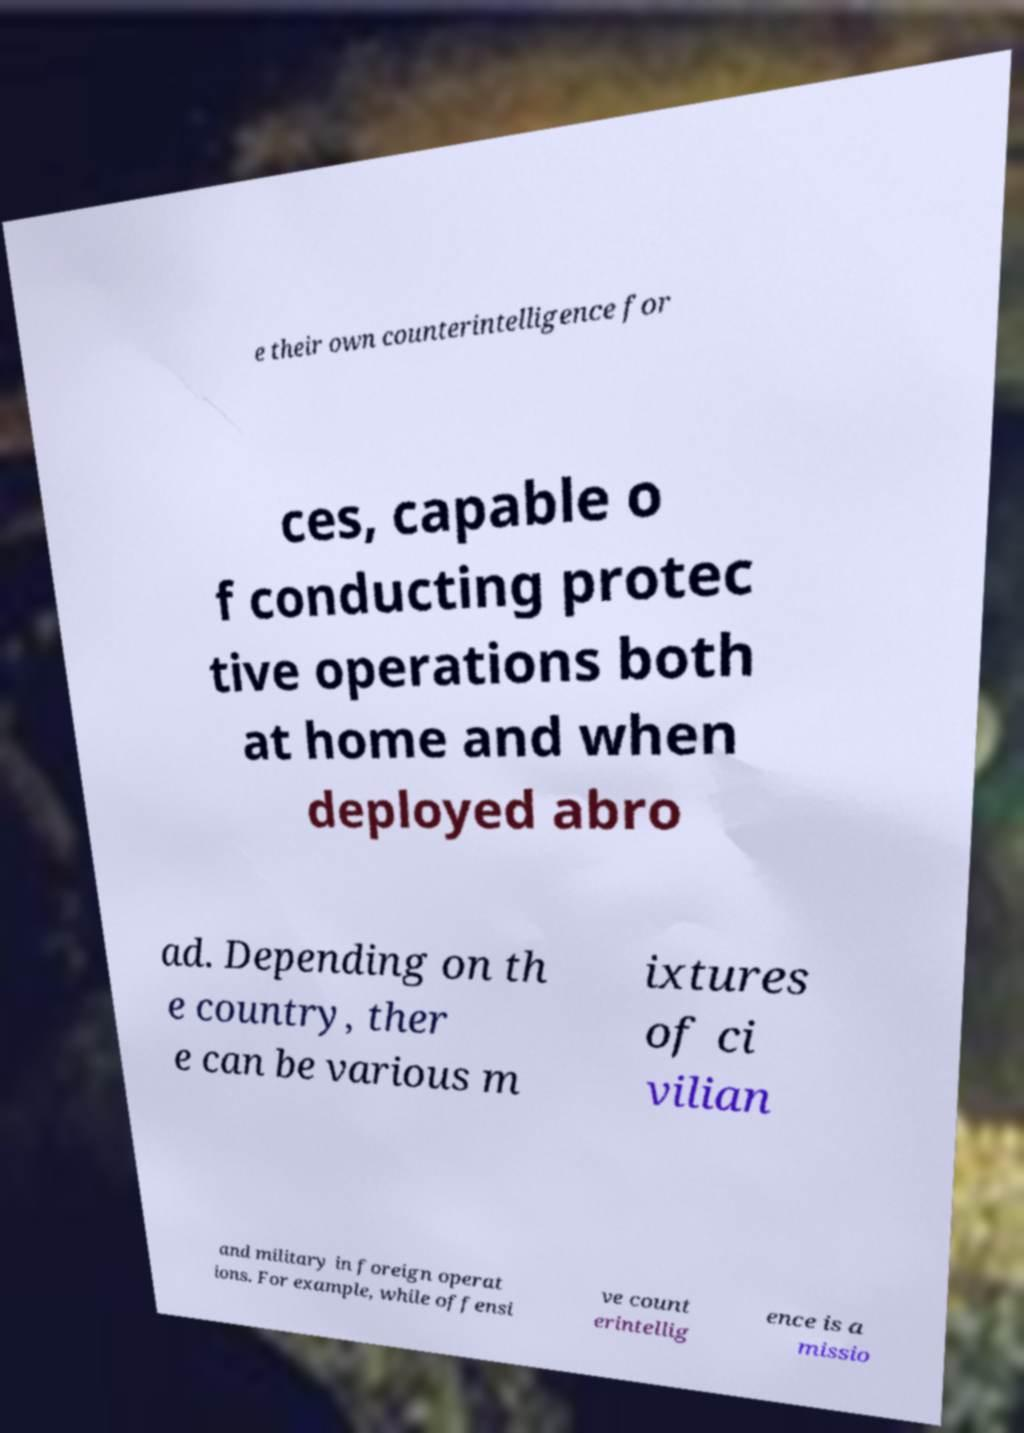What messages or text are displayed in this image? I need them in a readable, typed format. e their own counterintelligence for ces, capable o f conducting protec tive operations both at home and when deployed abro ad. Depending on th e country, ther e can be various m ixtures of ci vilian and military in foreign operat ions. For example, while offensi ve count erintellig ence is a missio 